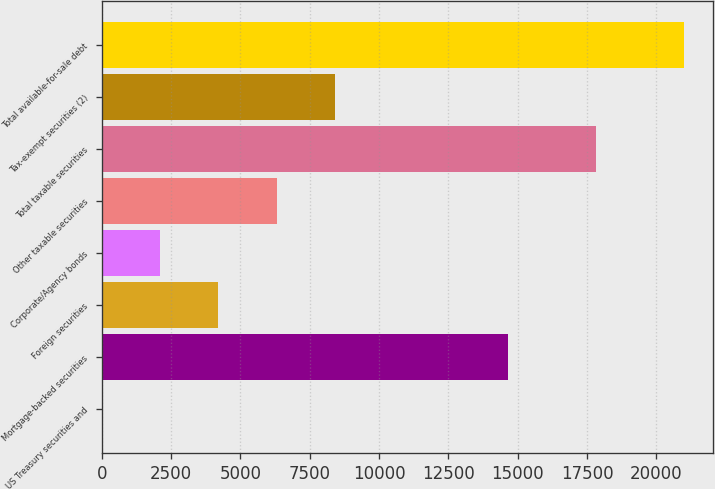Convert chart to OTSL. <chart><loc_0><loc_0><loc_500><loc_500><bar_chart><fcel>US Treasury securities and<fcel>Mortgage-backed securities<fcel>Foreign securities<fcel>Corporate/Agency bonds<fcel>Other taxable securities<fcel>Total taxable securities<fcel>Tax-exempt securities (2)<fcel>Total available-for-sale debt<nl><fcel>6<fcel>14644<fcel>4204.6<fcel>2105.3<fcel>6303.9<fcel>17828<fcel>8403.2<fcel>20999<nl></chart> 